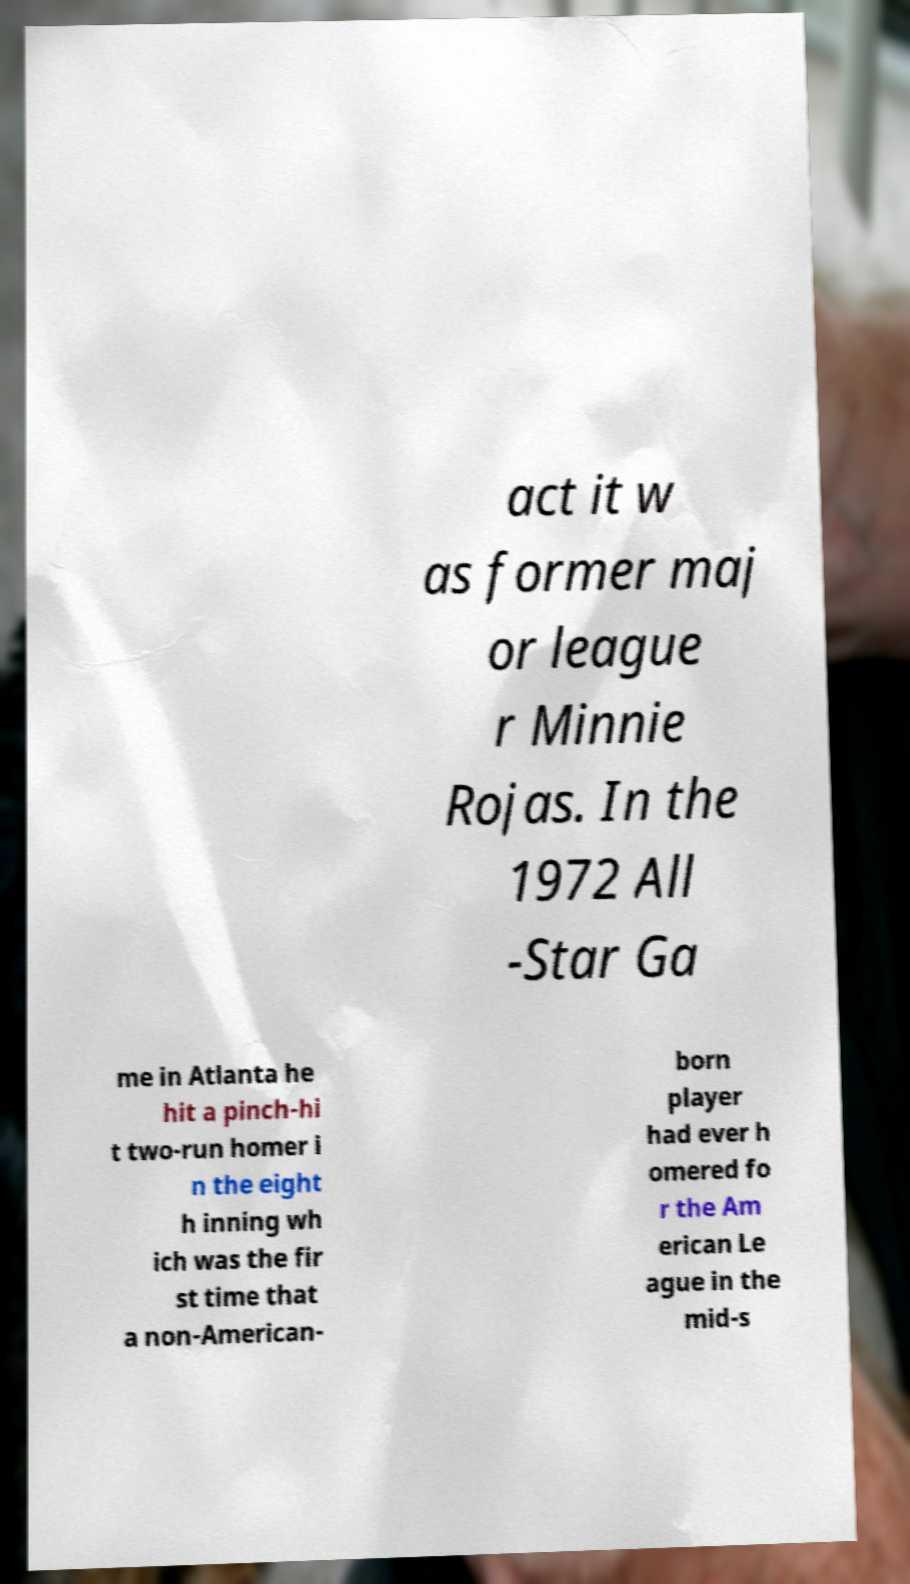Could you extract and type out the text from this image? act it w as former maj or league r Minnie Rojas. In the 1972 All -Star Ga me in Atlanta he hit a pinch-hi t two-run homer i n the eight h inning wh ich was the fir st time that a non-American- born player had ever h omered fo r the Am erican Le ague in the mid-s 